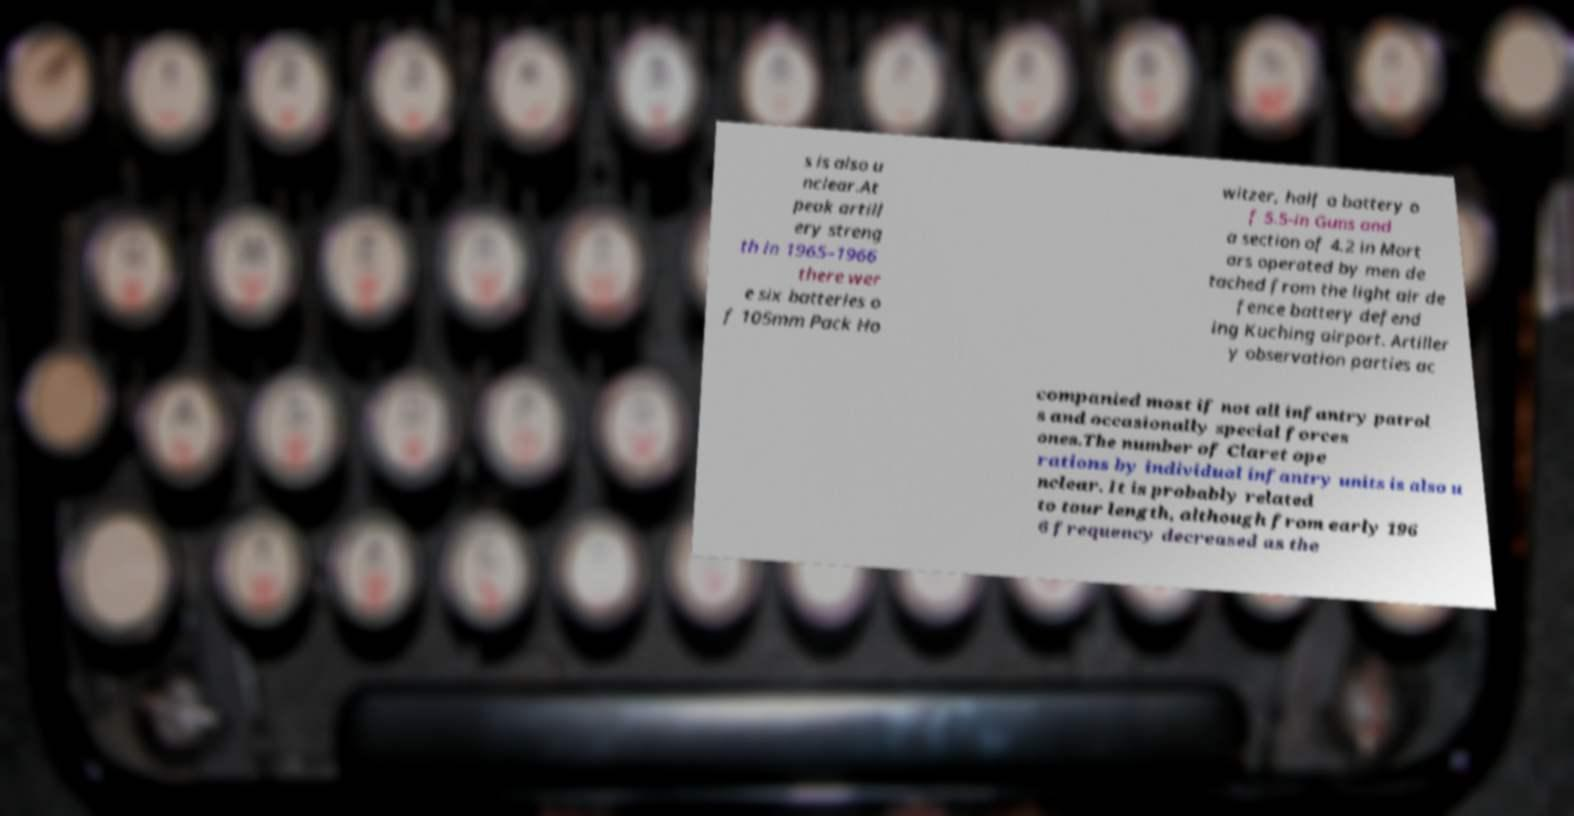Can you accurately transcribe the text from the provided image for me? s is also u nclear.At peak artill ery streng th in 1965–1966 there wer e six batteries o f 105mm Pack Ho witzer, half a battery o f 5.5-in Guns and a section of 4.2 in Mort ars operated by men de tached from the light air de fence battery defend ing Kuching airport. Artiller y observation parties ac companied most if not all infantry patrol s and occasionally special forces ones.The number of Claret ope rations by individual infantry units is also u nclear. It is probably related to tour length, although from early 196 6 frequency decreased as the 